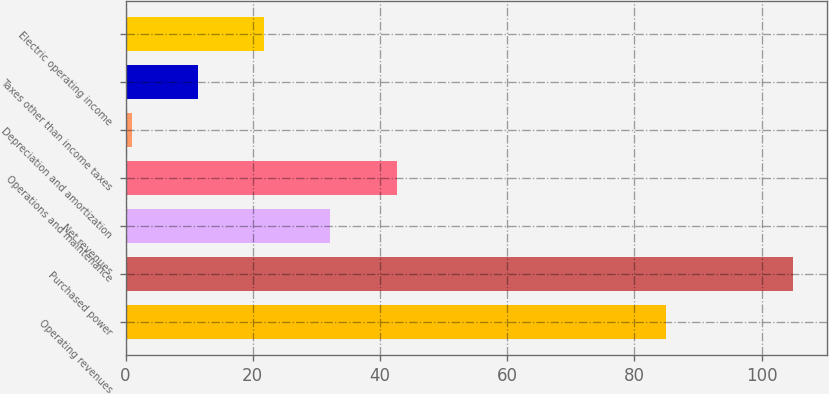<chart> <loc_0><loc_0><loc_500><loc_500><bar_chart><fcel>Operating revenues<fcel>Purchased power<fcel>Net revenues<fcel>Operations and maintenance<fcel>Depreciation and amortization<fcel>Taxes other than income taxes<fcel>Electric operating income<nl><fcel>85<fcel>105<fcel>32.2<fcel>42.6<fcel>1<fcel>11.4<fcel>21.8<nl></chart> 